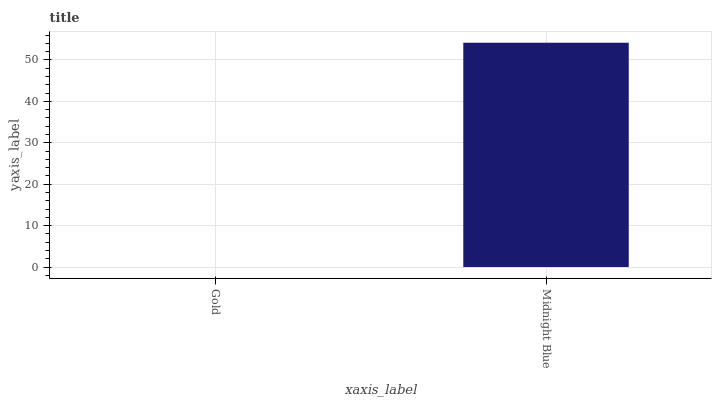Is Gold the minimum?
Answer yes or no. Yes. Is Midnight Blue the maximum?
Answer yes or no. Yes. Is Midnight Blue the minimum?
Answer yes or no. No. Is Midnight Blue greater than Gold?
Answer yes or no. Yes. Is Gold less than Midnight Blue?
Answer yes or no. Yes. Is Gold greater than Midnight Blue?
Answer yes or no. No. Is Midnight Blue less than Gold?
Answer yes or no. No. Is Midnight Blue the high median?
Answer yes or no. Yes. Is Gold the low median?
Answer yes or no. Yes. Is Gold the high median?
Answer yes or no. No. Is Midnight Blue the low median?
Answer yes or no. No. 